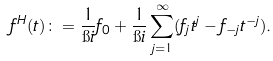Convert formula to latex. <formula><loc_0><loc_0><loc_500><loc_500>f ^ { H } ( t ) \colon = \frac { 1 } { \i i } f _ { 0 } + \frac { 1 } { \i i } \sum _ { j = 1 } ^ { \infty } ( f _ { j } t ^ { j } - f _ { - j } t ^ { - j } ) .</formula> 